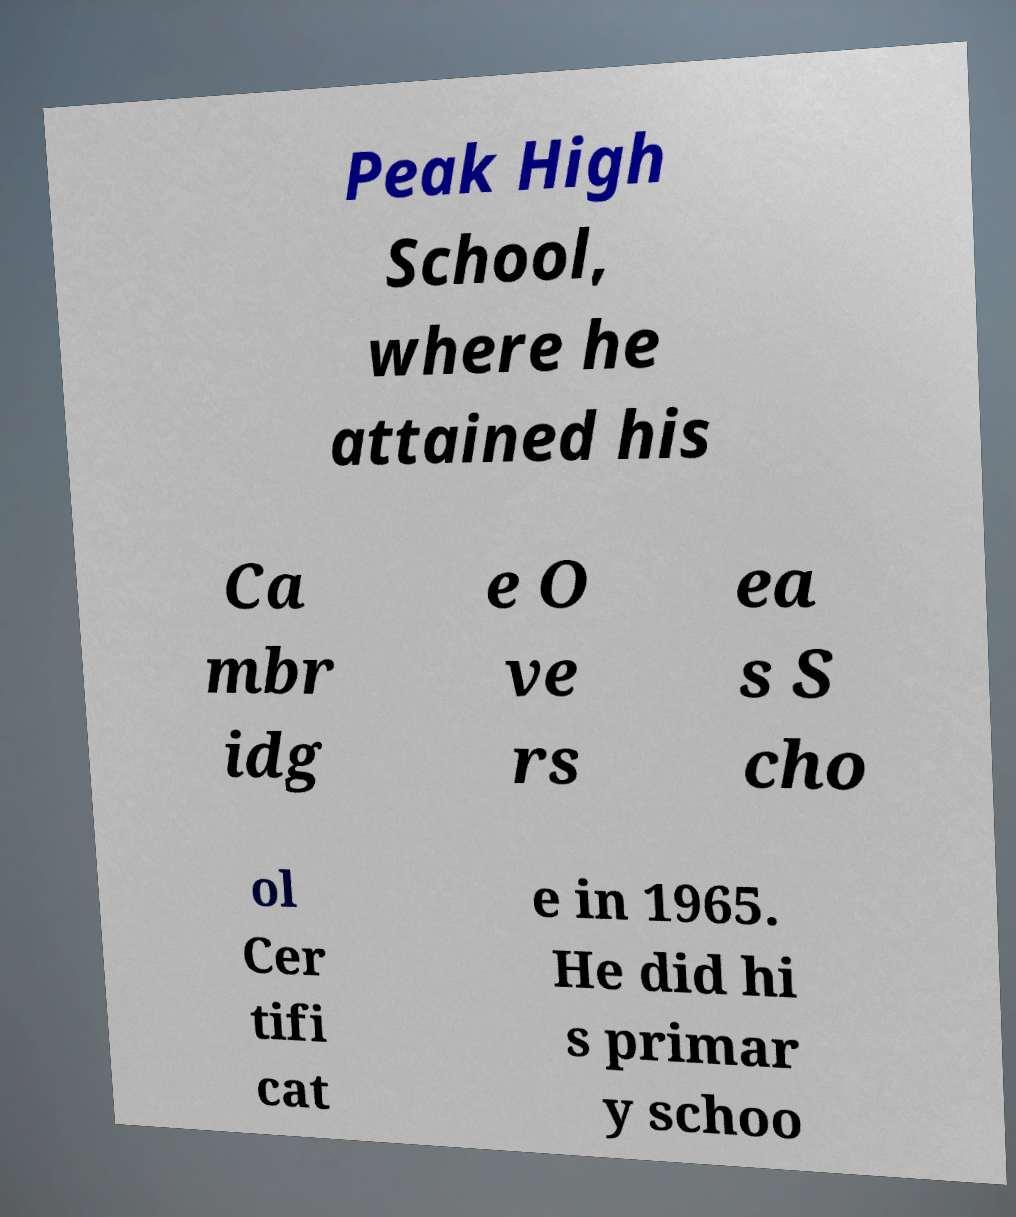There's text embedded in this image that I need extracted. Can you transcribe it verbatim? Peak High School, where he attained his Ca mbr idg e O ve rs ea s S cho ol Cer tifi cat e in 1965. He did hi s primar y schoo 